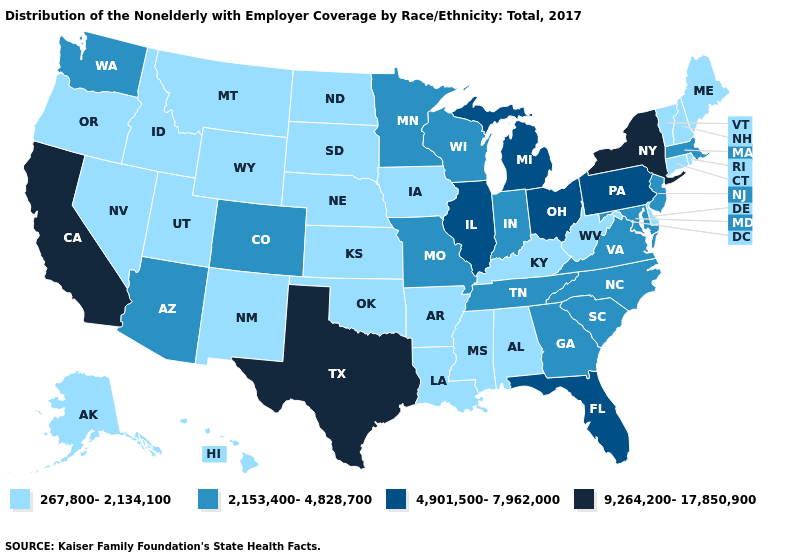Does South Dakota have the highest value in the MidWest?
Answer briefly. No. Which states hav the highest value in the Northeast?
Keep it brief. New York. What is the lowest value in the USA?
Concise answer only. 267,800-2,134,100. Is the legend a continuous bar?
Quick response, please. No. What is the value of Mississippi?
Quick response, please. 267,800-2,134,100. Name the states that have a value in the range 9,264,200-17,850,900?
Write a very short answer. California, New York, Texas. What is the value of Alaska?
Keep it brief. 267,800-2,134,100. Name the states that have a value in the range 2,153,400-4,828,700?
Keep it brief. Arizona, Colorado, Georgia, Indiana, Maryland, Massachusetts, Minnesota, Missouri, New Jersey, North Carolina, South Carolina, Tennessee, Virginia, Washington, Wisconsin. What is the highest value in states that border Illinois?
Keep it brief. 2,153,400-4,828,700. Name the states that have a value in the range 4,901,500-7,962,000?
Answer briefly. Florida, Illinois, Michigan, Ohio, Pennsylvania. Is the legend a continuous bar?
Short answer required. No. What is the value of Connecticut?
Answer briefly. 267,800-2,134,100. Does New York have the highest value in the USA?
Concise answer only. Yes. Among the states that border Delaware , does Maryland have the highest value?
Write a very short answer. No. Name the states that have a value in the range 4,901,500-7,962,000?
Be succinct. Florida, Illinois, Michigan, Ohio, Pennsylvania. 